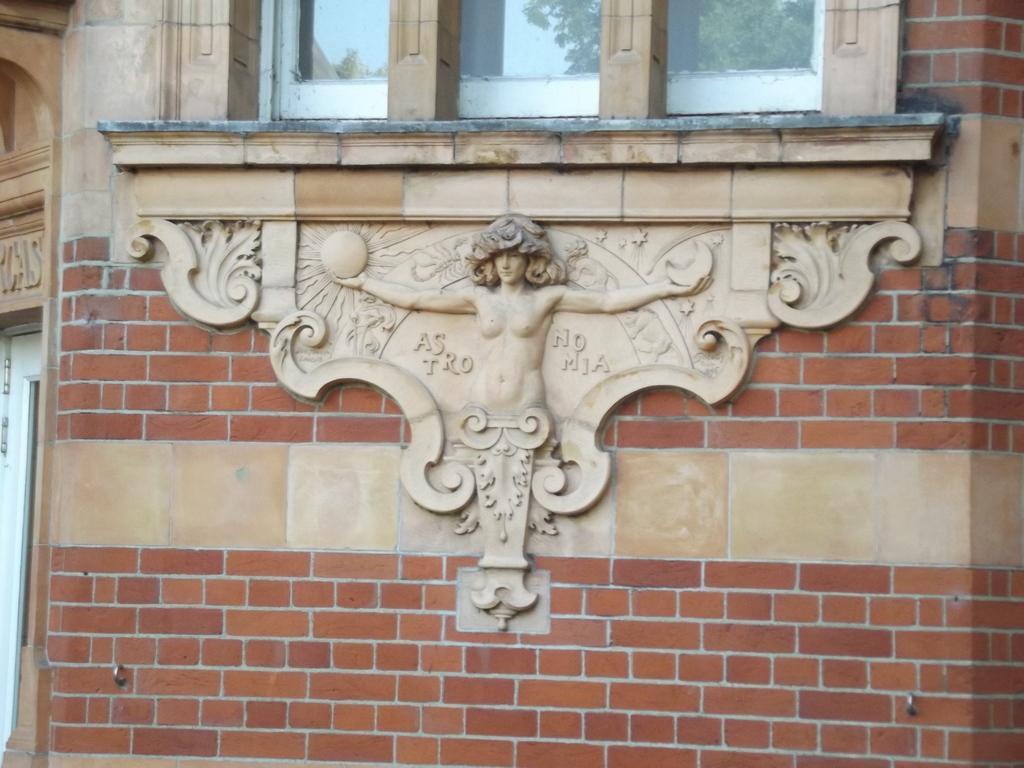Please provide a concise description of this image. In this image I can see the statue to the wall. And I can see the red color brick wall to the building. In the top I can see the window and there are trees and the sky can be see through it. 